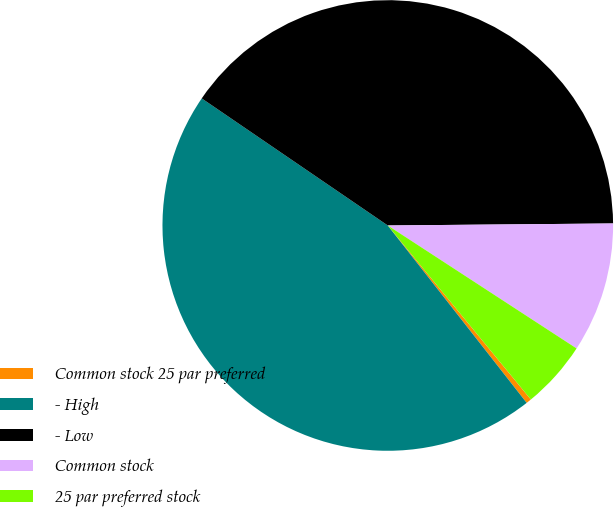<chart> <loc_0><loc_0><loc_500><loc_500><pie_chart><fcel>Common stock 25 par preferred<fcel>- High<fcel>- Low<fcel>Common stock<fcel>25 par preferred stock<nl><fcel>0.38%<fcel>45.11%<fcel>40.32%<fcel>9.33%<fcel>4.86%<nl></chart> 